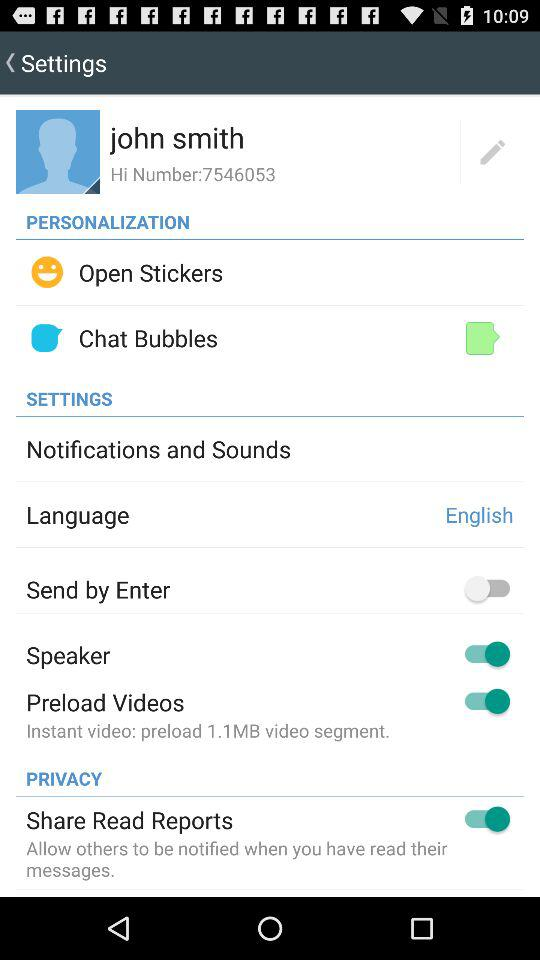How many MB are shown in "Preload Videos"? There are 1.1 MB shown in "Preload Videos". 